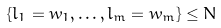<formula> <loc_0><loc_0><loc_500><loc_500>\{ l _ { 1 } = w _ { 1 } , \dots , l _ { m } = w _ { m } \} \leq N</formula> 